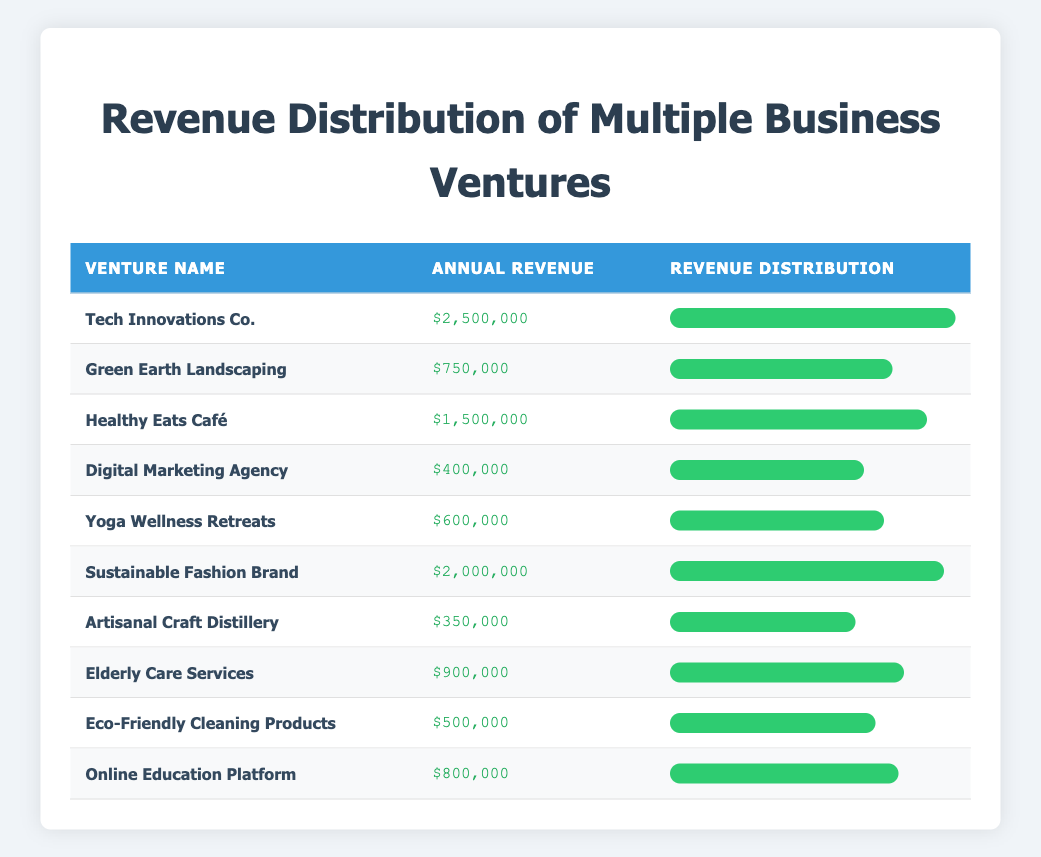What is the annual revenue of Yoga Wellness Retreats? The table directly lists the annual revenue for Yoga Wellness Retreats as $600,000.
Answer: $600,000 Which venture has the highest annual revenue? By examining the revenue values in the table, Tech Innovations Co. has the highest annual revenue at $2,500,000.
Answer: Tech Innovations Co What is the total annual revenue of all business ventures combined? Summing all venture revenues: 2500000 + 750000 + 1500000 + 400000 + 600000 + 2000000 + 350000 + 900000 + 500000 + 800000 = $8,300,000.
Answer: $8,300,000 Is the annual revenue of Sustainable Fashion Brand greater than $1,500,000? The table shows that the annual revenue of Sustainable Fashion Brand is $2,000,000, which is greater than $1,500,000. Therefore, the answer is yes.
Answer: Yes What is the average annual revenue of the ventures involved in health and wellness (Yoga Wellness Retreats and Healthy Eats Café)? The revenues for Yoga Wellness Retreats and Healthy Eats Café are $600,000 and $1,500,000, respectively. The sum is $600,000 + $1,500,000 = $2,100,000. Dividing this total by 2 gives an average of $1,050,000.
Answer: $1,050,000 Which two ventures have the lowest annual revenues? The lowest annual revenues are those of Artisanal Craft Distillery at $350,000 and Digital Marketing Agency at $400,000.
Answer: Artisanal Craft Distillery and Digital Marketing Agency What percentage of the total revenue does Green Earth Landscaping contribute? First, Green Earth Landscaping's revenue is $750,000. The total revenue is $8,300,000. Thus, the percentage is ($750,000 / $8,300,000) × 100 ≈ 9.05%.
Answer: Approximately 9.05% Are there any ventures with annual revenues below $500,000? The table lists Artisanal Craft Distillery with an annual revenue of $350,000, which is below $500,000. Thus, the answer is yes.
Answer: Yes What is the difference in annual revenue between the highest and lowest revenue ventures? The highest revenue venture is Tech Innovations Co. with $2,500,000 and the lowest is Artisanal Craft Distillery with $350,000. The difference is $2,500,000 - $350,000 = $2,150,000.
Answer: $2,150,000 